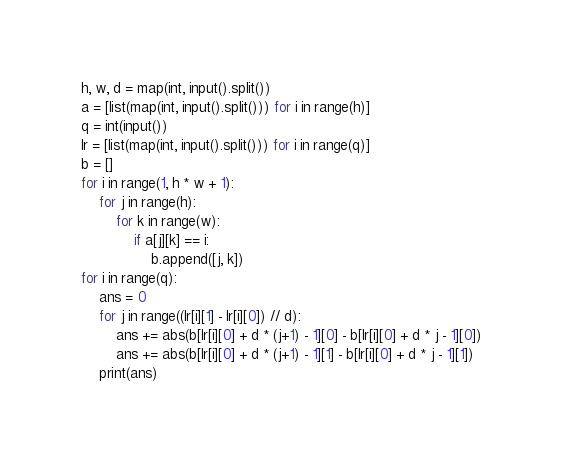<code> <loc_0><loc_0><loc_500><loc_500><_Python_>h, w, d = map(int, input().split())
a = [list(map(int, input().split())) for i in range(h)]
q = int(input())
lr = [list(map(int, input().split())) for i in range(q)]
b = []
for i in range(1, h * w + 1):
    for j in range(h):
        for k in range(w):
            if a[j][k] == i:
                b.append([j, k])
for i in range(q):
    ans = 0
    for j in range((lr[i][1] - lr[i][0]) // d):
        ans += abs(b[lr[i][0] + d * (j+1) - 1][0] - b[lr[i][0] + d * j - 1][0])
        ans += abs(b[lr[i][0] + d * (j+1) - 1][1] - b[lr[i][0] + d * j - 1][1])
    print(ans)
</code> 